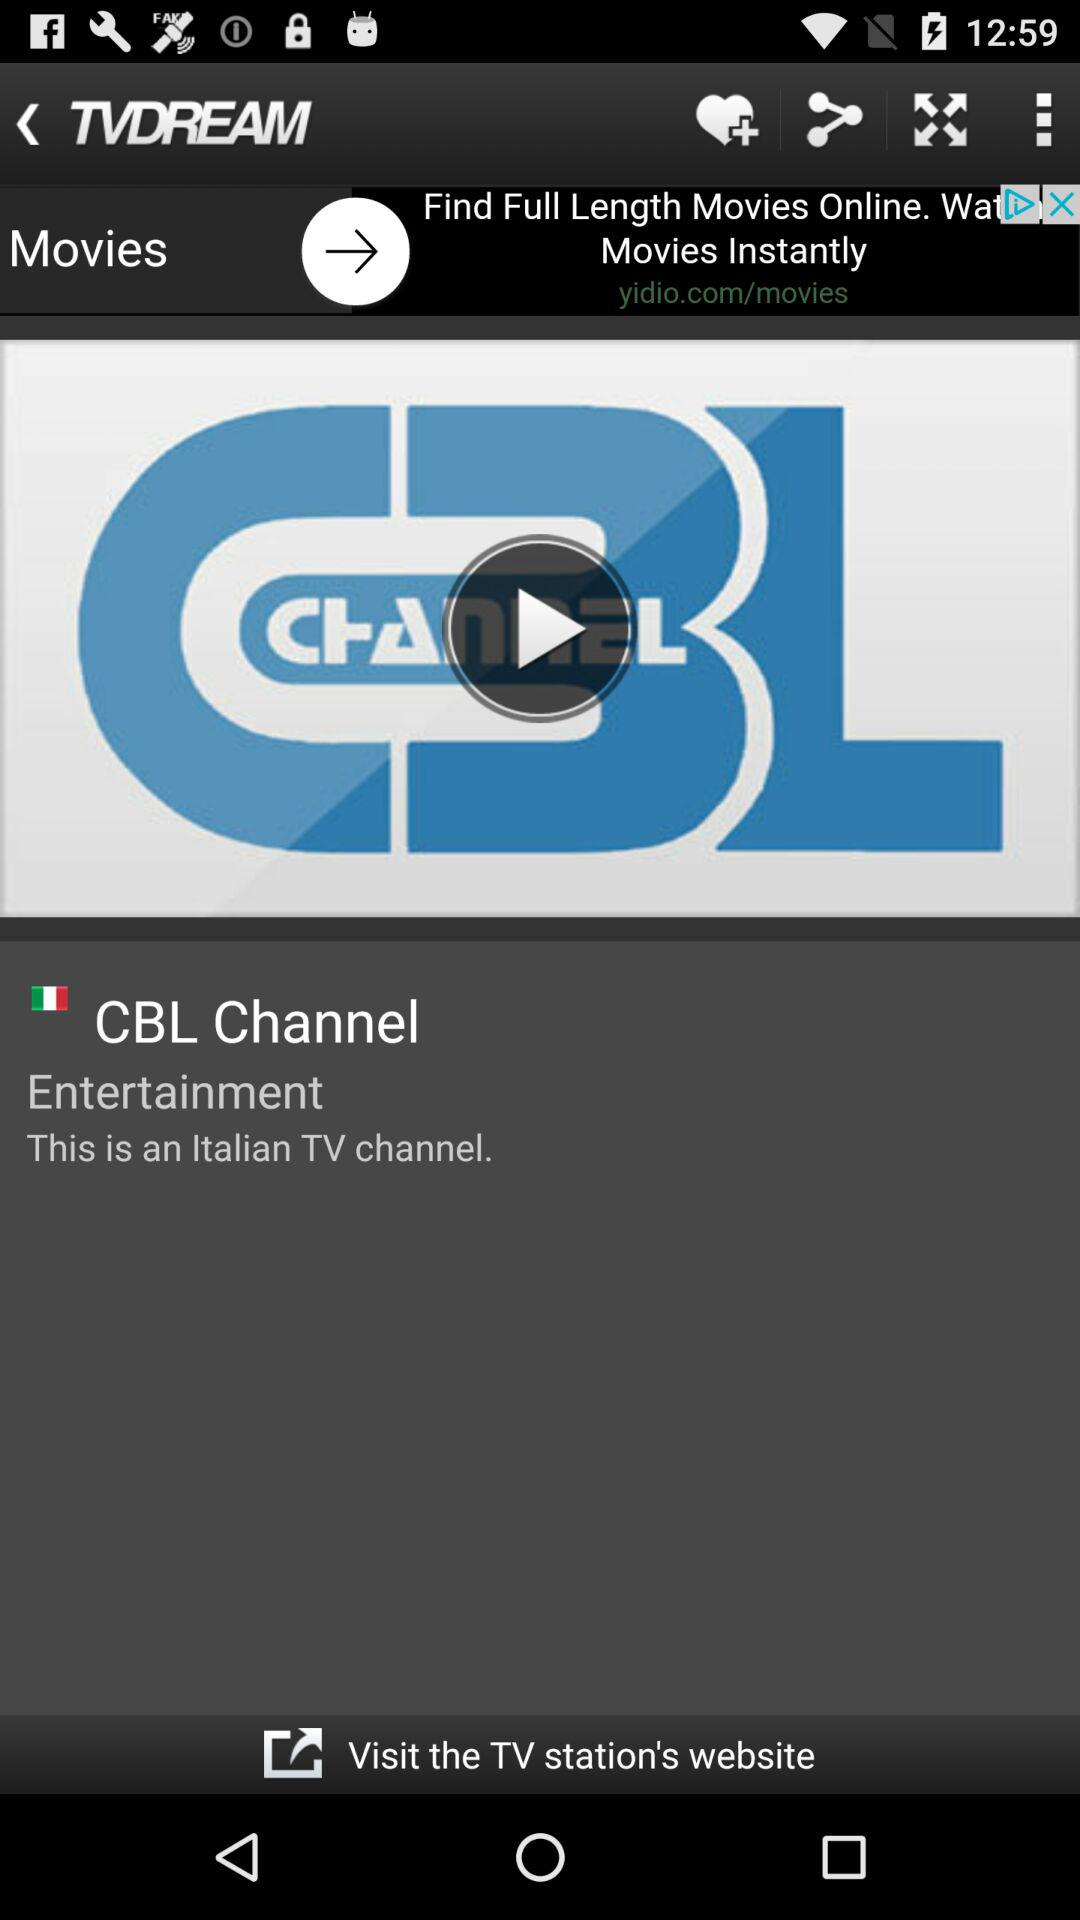What is the channel name? The channel name is "CBL Channel". 